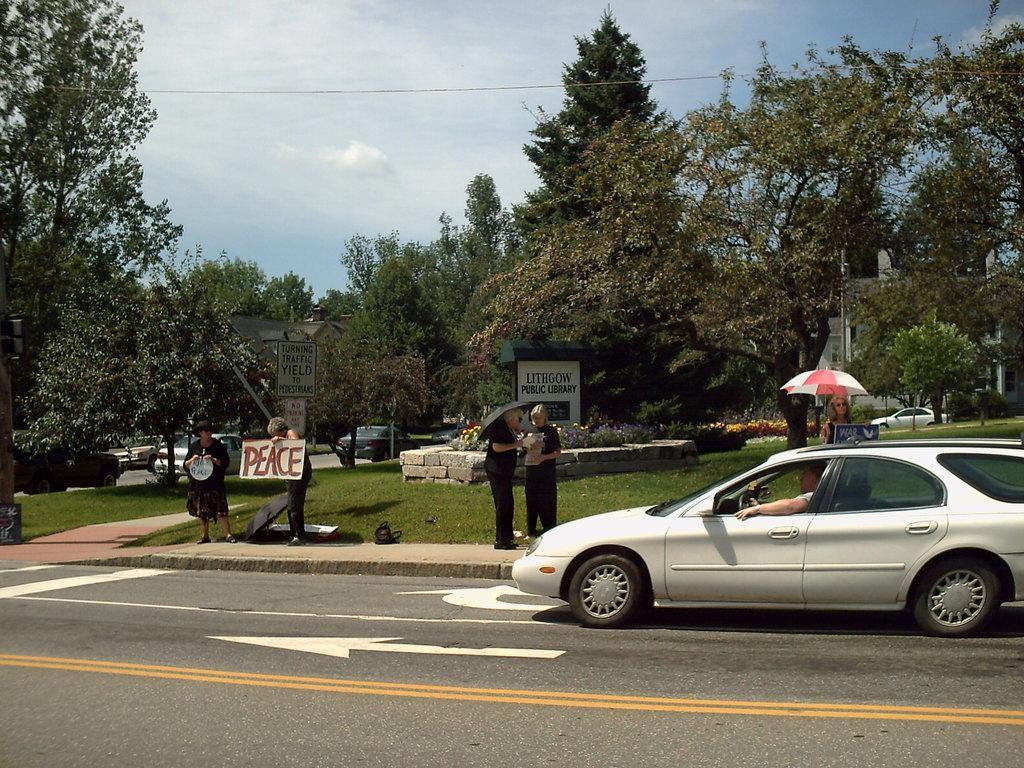Please provide a concise description of this image. In this image there is a car on the road. On the sidewalk few people are standing, few are holding umbrella. A lady is holding a placard. On it ¨PEACE ¨ is written. In the background there are trees, buildings. On the road there are few vehicles. The sky is cloudy. 